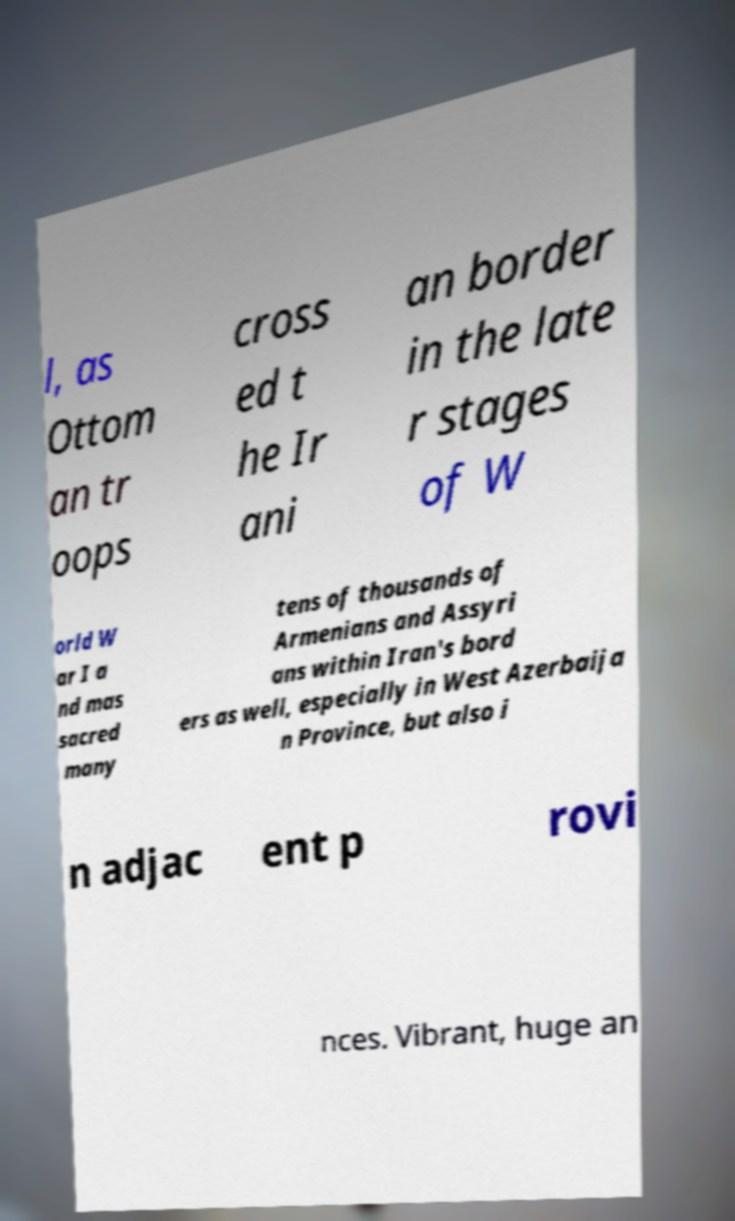What messages or text are displayed in this image? I need them in a readable, typed format. l, as Ottom an tr oops cross ed t he Ir ani an border in the late r stages of W orld W ar I a nd mas sacred many tens of thousands of Armenians and Assyri ans within Iran's bord ers as well, especially in West Azerbaija n Province, but also i n adjac ent p rovi nces. Vibrant, huge an 